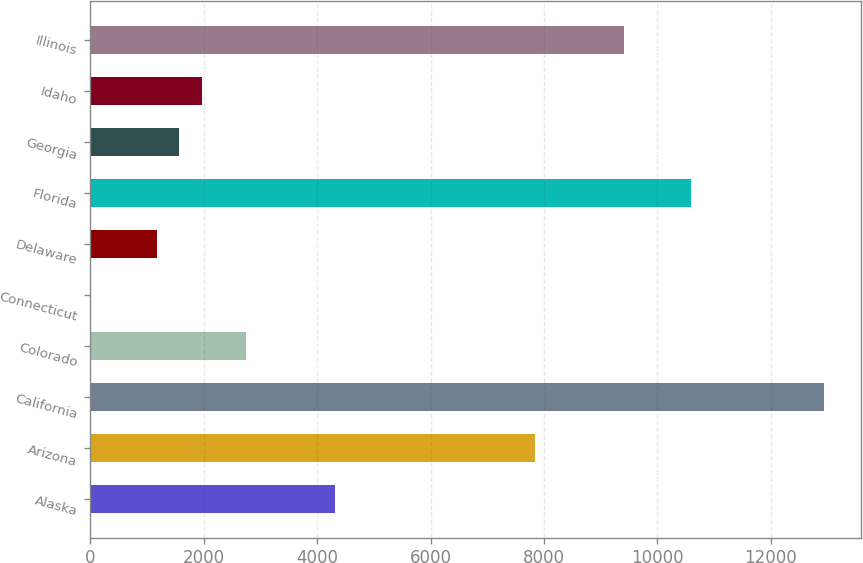Convert chart to OTSL. <chart><loc_0><loc_0><loc_500><loc_500><bar_chart><fcel>Alaska<fcel>Arizona<fcel>California<fcel>Colorado<fcel>Connecticut<fcel>Delaware<fcel>Florida<fcel>Georgia<fcel>Idaho<fcel>Illinois<nl><fcel>4315.2<fcel>7845<fcel>12943.6<fcel>2746.4<fcel>1<fcel>1177.6<fcel>10590.4<fcel>1569.8<fcel>1962<fcel>9413.8<nl></chart> 